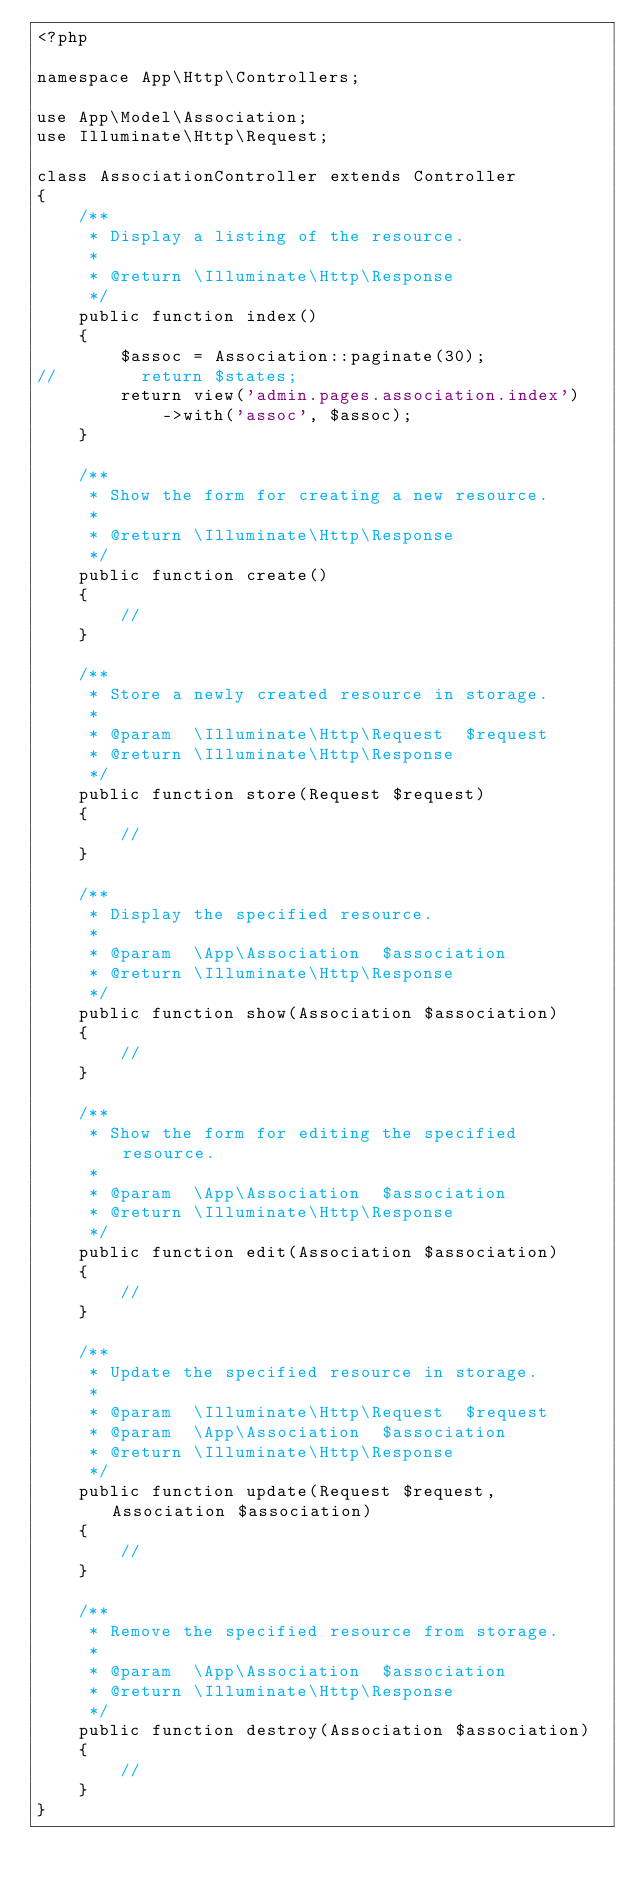Convert code to text. <code><loc_0><loc_0><loc_500><loc_500><_PHP_><?php

namespace App\Http\Controllers;

use App\Model\Association;
use Illuminate\Http\Request;

class AssociationController extends Controller
{
    /**
     * Display a listing of the resource.
     *
     * @return \Illuminate\Http\Response
     */
    public function index()
    {
        $assoc = Association::paginate(30);
//        return $states;
        return view('admin.pages.association.index')
            ->with('assoc', $assoc);
    }

    /**
     * Show the form for creating a new resource.
     *
     * @return \Illuminate\Http\Response
     */
    public function create()
    {
        //
    }

    /**
     * Store a newly created resource in storage.
     *
     * @param  \Illuminate\Http\Request  $request
     * @return \Illuminate\Http\Response
     */
    public function store(Request $request)
    {
        //
    }

    /**
     * Display the specified resource.
     *
     * @param  \App\Association  $association
     * @return \Illuminate\Http\Response
     */
    public function show(Association $association)
    {
        //
    }

    /**
     * Show the form for editing the specified resource.
     *
     * @param  \App\Association  $association
     * @return \Illuminate\Http\Response
     */
    public function edit(Association $association)
    {
        //
    }

    /**
     * Update the specified resource in storage.
     *
     * @param  \Illuminate\Http\Request  $request
     * @param  \App\Association  $association
     * @return \Illuminate\Http\Response
     */
    public function update(Request $request, Association $association)
    {
        //
    }

    /**
     * Remove the specified resource from storage.
     *
     * @param  \App\Association  $association
     * @return \Illuminate\Http\Response
     */
    public function destroy(Association $association)
    {
        //
    }
}
</code> 